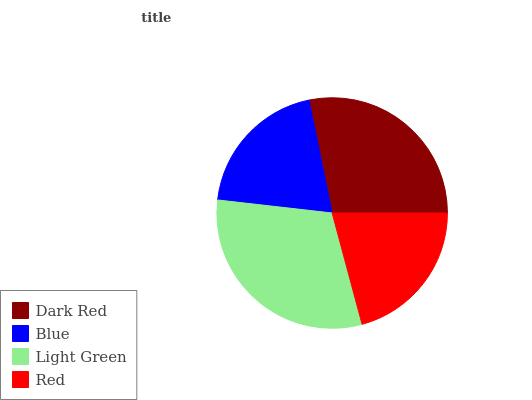Is Blue the minimum?
Answer yes or no. Yes. Is Light Green the maximum?
Answer yes or no. Yes. Is Light Green the minimum?
Answer yes or no. No. Is Blue the maximum?
Answer yes or no. No. Is Light Green greater than Blue?
Answer yes or no. Yes. Is Blue less than Light Green?
Answer yes or no. Yes. Is Blue greater than Light Green?
Answer yes or no. No. Is Light Green less than Blue?
Answer yes or no. No. Is Dark Red the high median?
Answer yes or no. Yes. Is Red the low median?
Answer yes or no. Yes. Is Red the high median?
Answer yes or no. No. Is Light Green the low median?
Answer yes or no. No. 